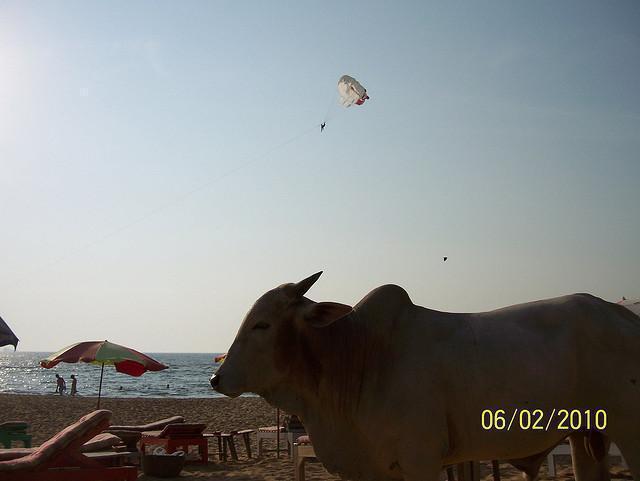What country is this beach located in?
Indicate the correct choice and explain in the format: 'Answer: answer
Rationale: rationale.'
Options: United states, canada, mexico, india. Answer: india.
Rationale: This is located in india. 